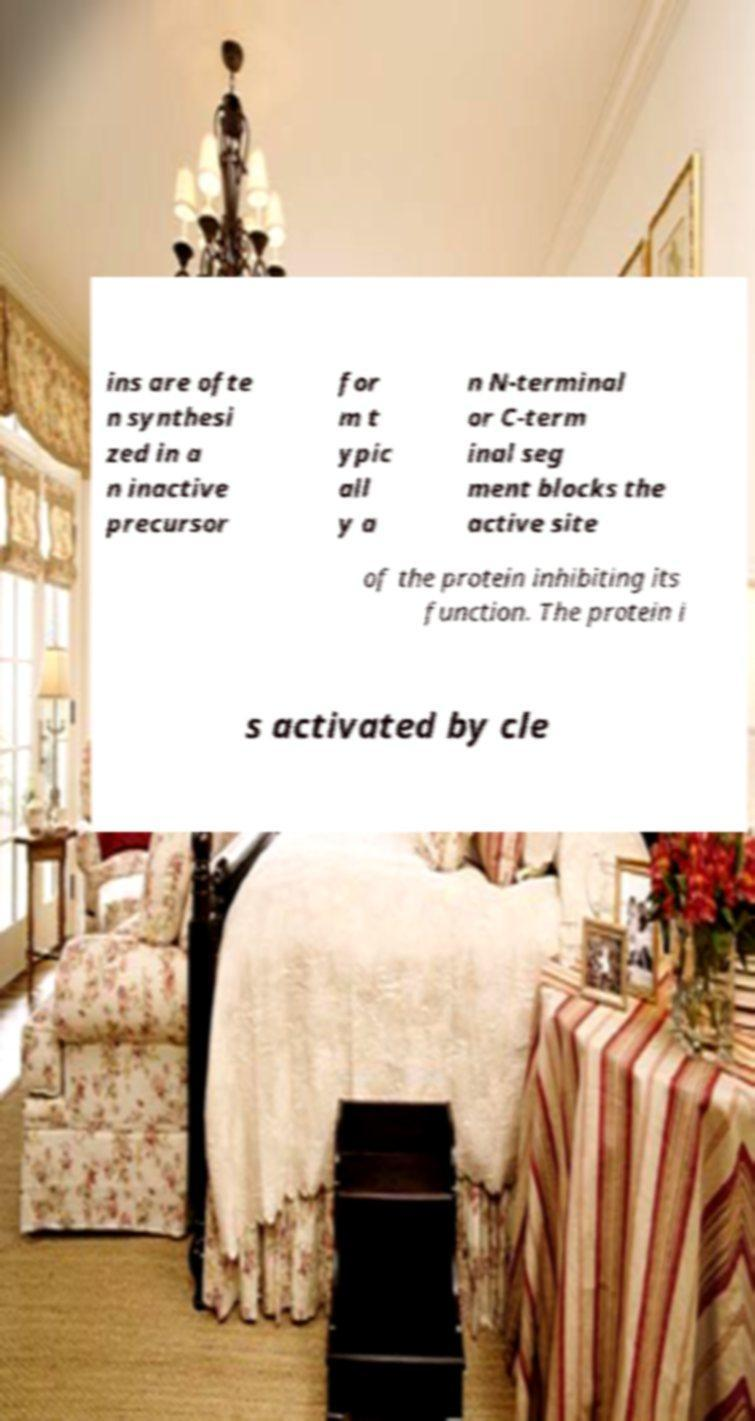Can you read and provide the text displayed in the image?This photo seems to have some interesting text. Can you extract and type it out for me? ins are ofte n synthesi zed in a n inactive precursor for m t ypic all y a n N-terminal or C-term inal seg ment blocks the active site of the protein inhibiting its function. The protein i s activated by cle 